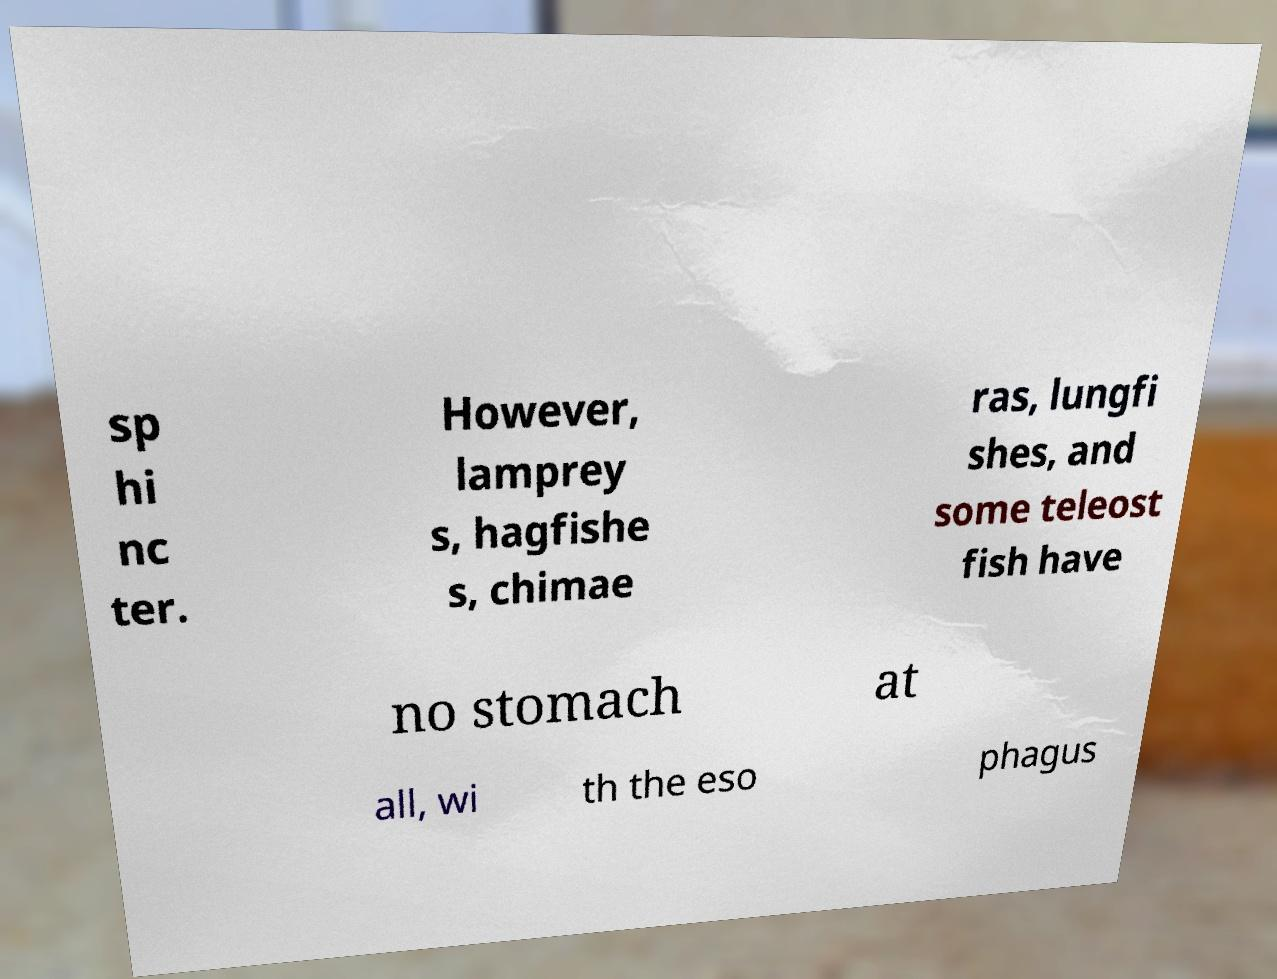Could you assist in decoding the text presented in this image and type it out clearly? sp hi nc ter. However, lamprey s, hagfishe s, chimae ras, lungfi shes, and some teleost fish have no stomach at all, wi th the eso phagus 